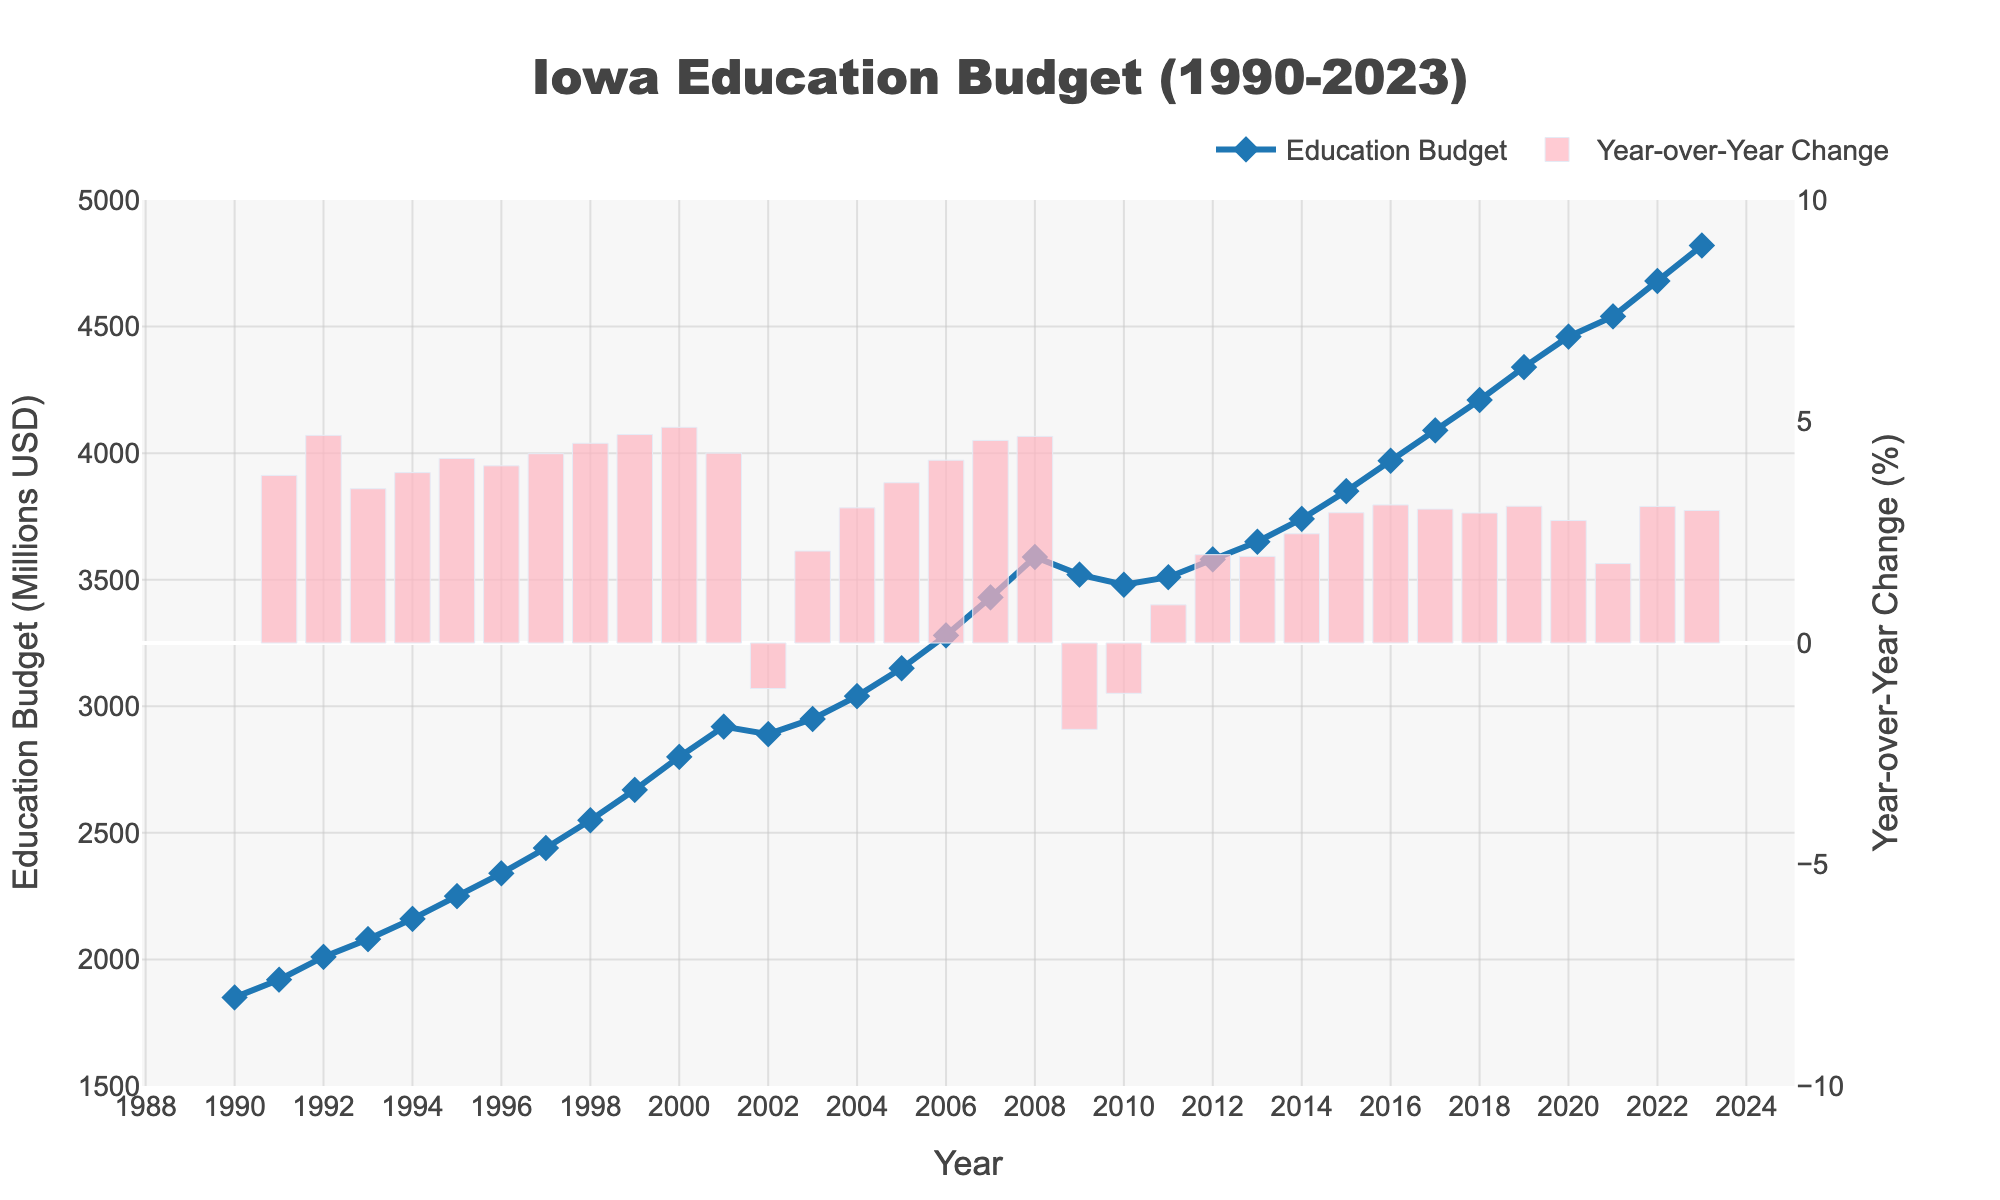How did the education budget change between 1990 and 2023? The education budget in 1990 was $1850 million and in 2023 it was $4820 million. The change is calculated as $4820 million - $1850 million = $2970 million.
Answer: $2970 million Which year had the highest education budget? By examining the line plot, the year with the highest data point on the y-axis corresponds to 2023.
Answer: 2023 In which year did the education budget show the greatest year-over-year increase? The tallest bar in the year-over-year change plot indicates the greatest increase, which happens in 2006.
Answer: 2006 What is the average yearly education budget between 2000 and 2010? Sum the yearly budgets from 2000 to 2010 and then divide by the number of years (11). The average calculation is ($2800 + $2920 + $2890 + $2950 + $3040 + $3150 + $3280 + $3430 + $3590 + $3520 + $3480) / 11 = $3168.18 million
Answer: $3168.18 million How many times did the education budget decrease year-over-year over the entire period? Identify the bars that extend below the x-axis in the year-over-year change plot. There are three such bars (2002, 2009, and 2010).
Answer: 3 When did the education budget first exceed $3000 million? Examine the line plot and identify the first year when the budget surpasses the $3000 million mark, which occurs in 2004.
Answer: 2004 Between 2005 and 2010, which year had the smallest education budget? Look at the line plot for the years 2005 to 2010 and find the lowest data point, which corresponds to 2010 with a budget of $3480 million.
Answer: 2010 What is the percentage increase in the education budget from 1995 to 2000? First calculate the increase in budget from 1995 ($2250 million) to 2000 ($2800 million), which is $2800 - $2250 = $550 million. Then, find the percentage increase: ($550 / $2250) * 100 = 24.44%.
Answer: 24.44% Which year had the greatest decrease in the education budget compared to the previous year? Identify the lowest point among the negative bars in the year-over-year change plot. This is in 2009.
Answer: 2009 What is the median value of the education budget from 1990 to 2023? List all the budget values in ascending order and find the middle value (or the average of the two middle values if the count is even). With 34 data points, the median is the average of the 17th and 18th values: ($3740 + $3850) / 2 = $3795 million
Answer: $3795 million 